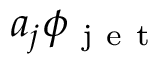Convert formula to latex. <formula><loc_0><loc_0><loc_500><loc_500>a _ { j } \phi _ { j e t }</formula> 